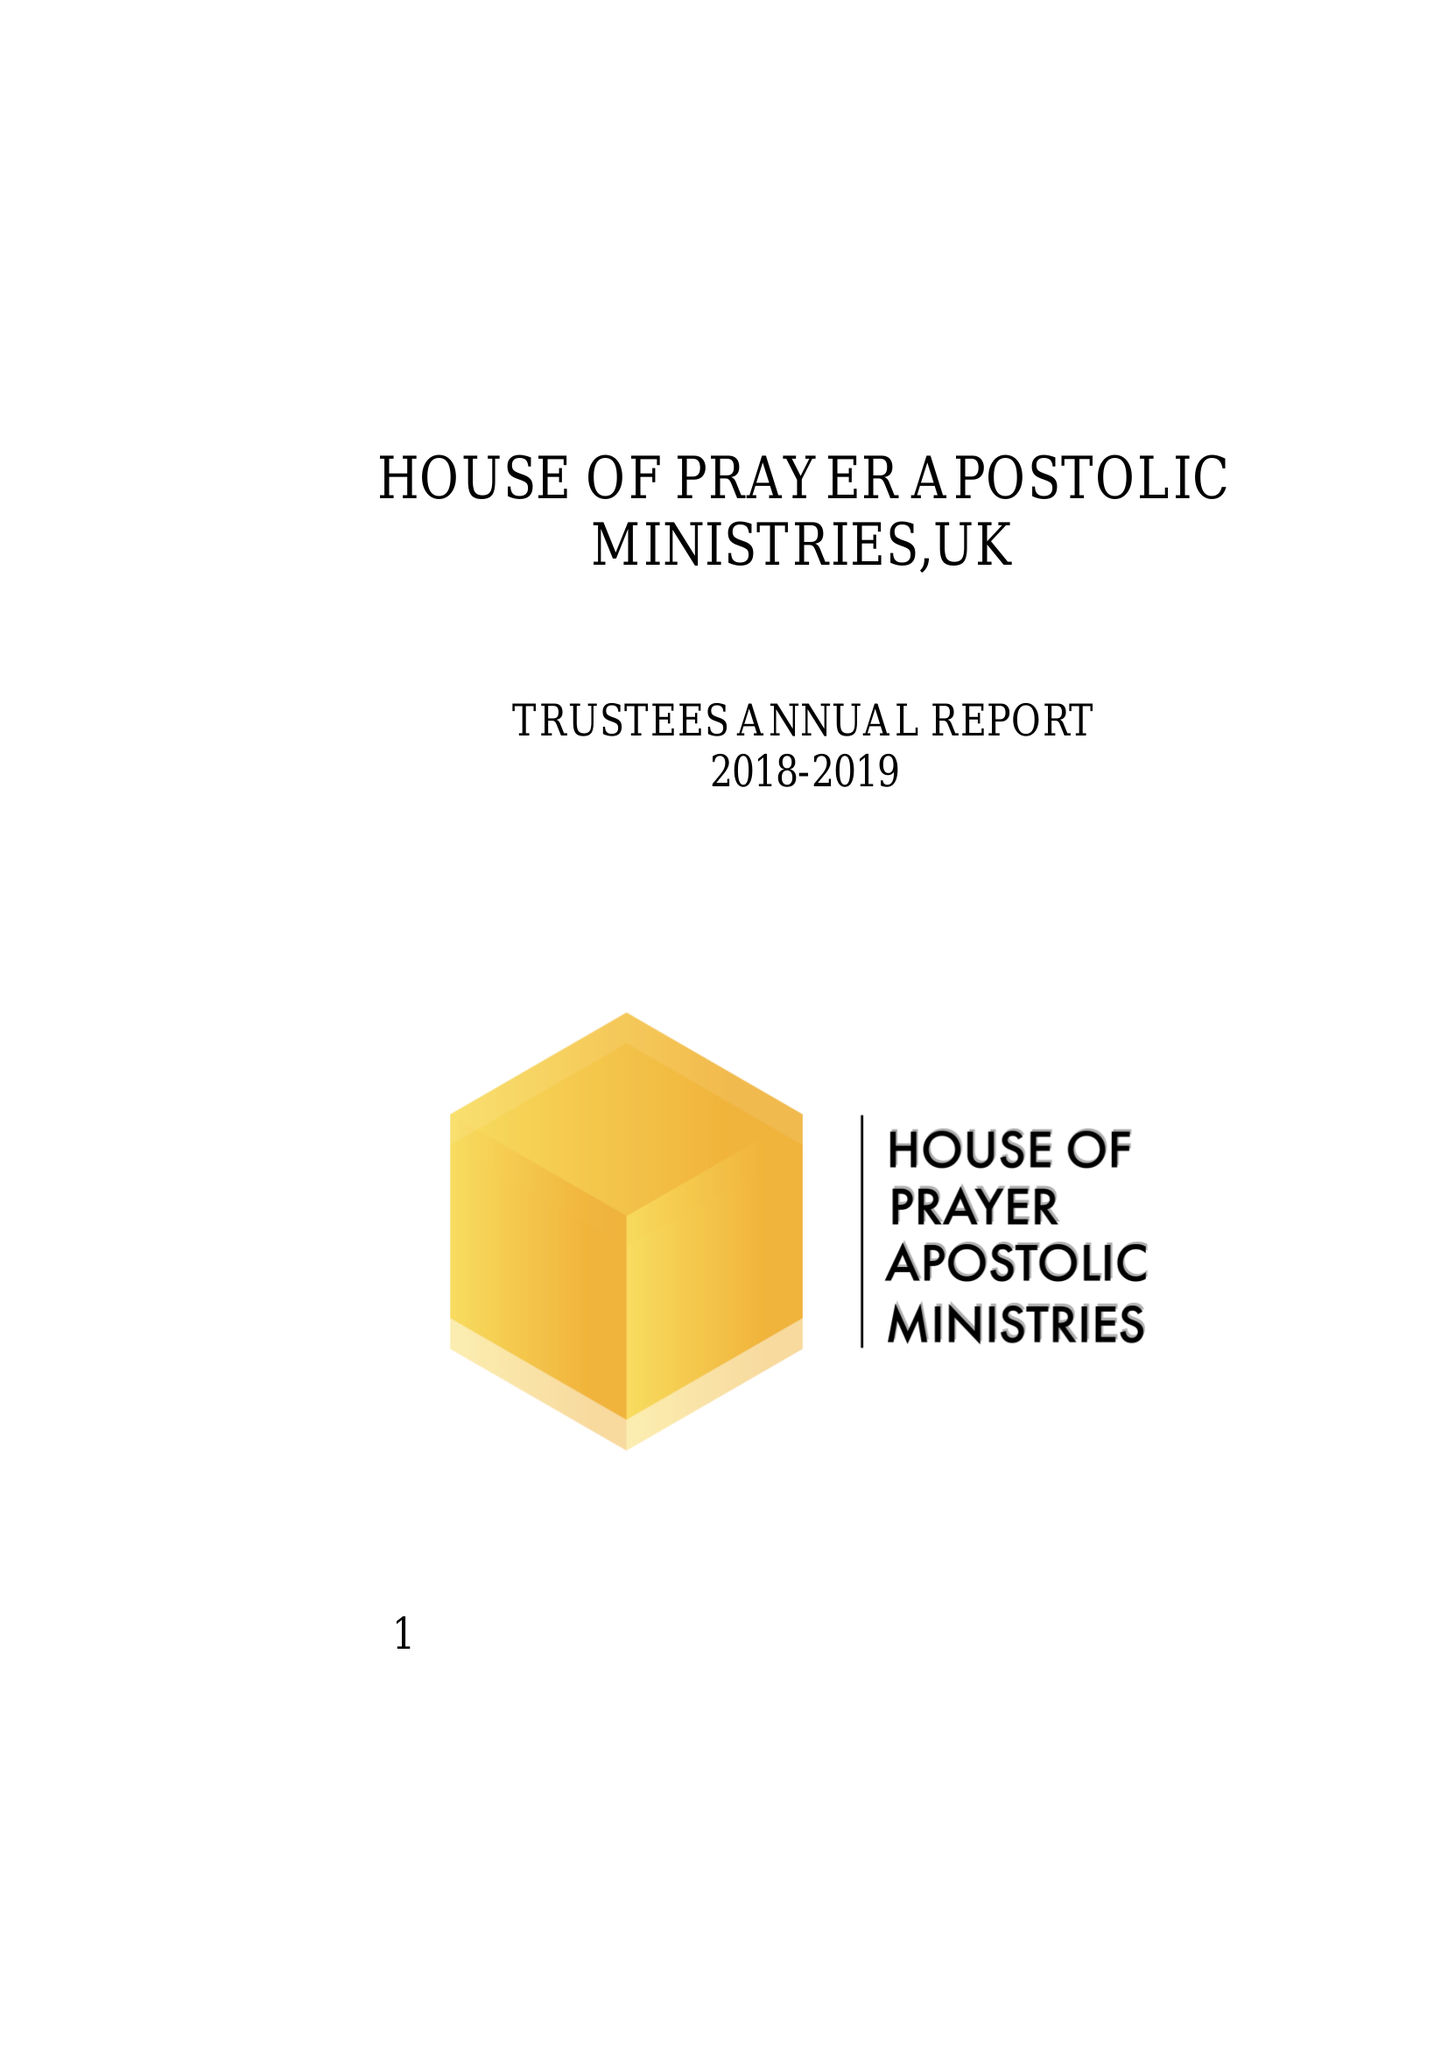What is the value for the charity_number?
Answer the question using a single word or phrase. 1158638 